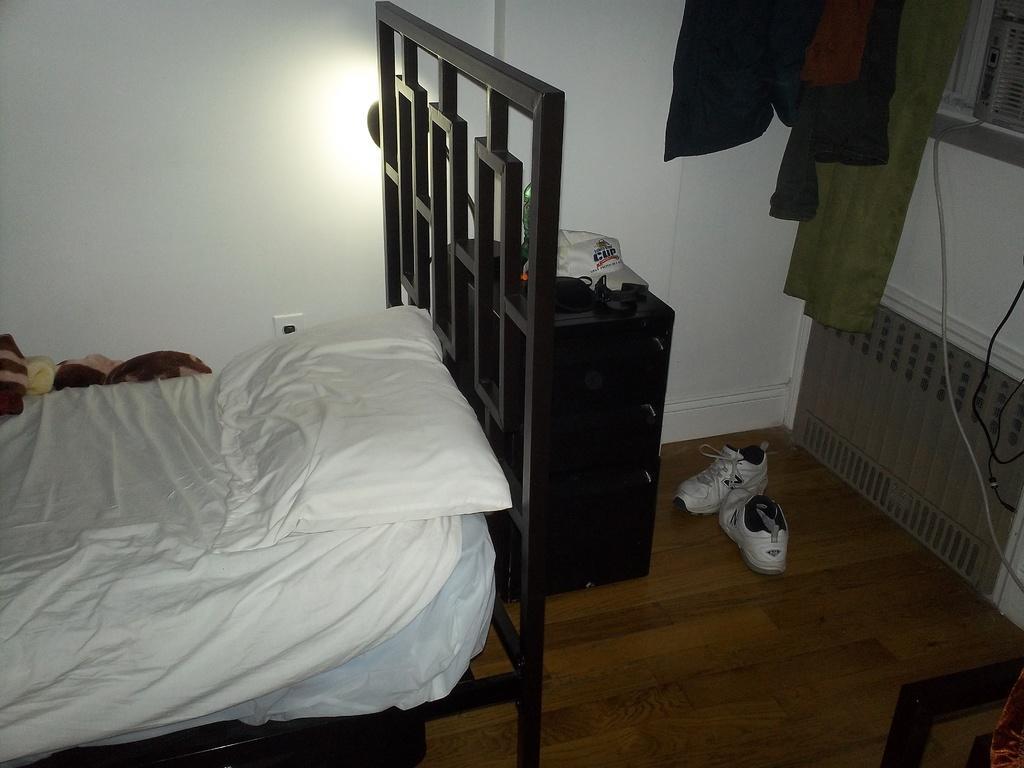How would you summarize this image in a sentence or two? In this image there is a bed having a pillow on it. Behind the bed there are few objects. Right side there is a table having a cap, bottle and few objects on it. There are shoes on the floor. Right top there are few clothes hanged. Background there is a wall. Right bottom there are few objects. 